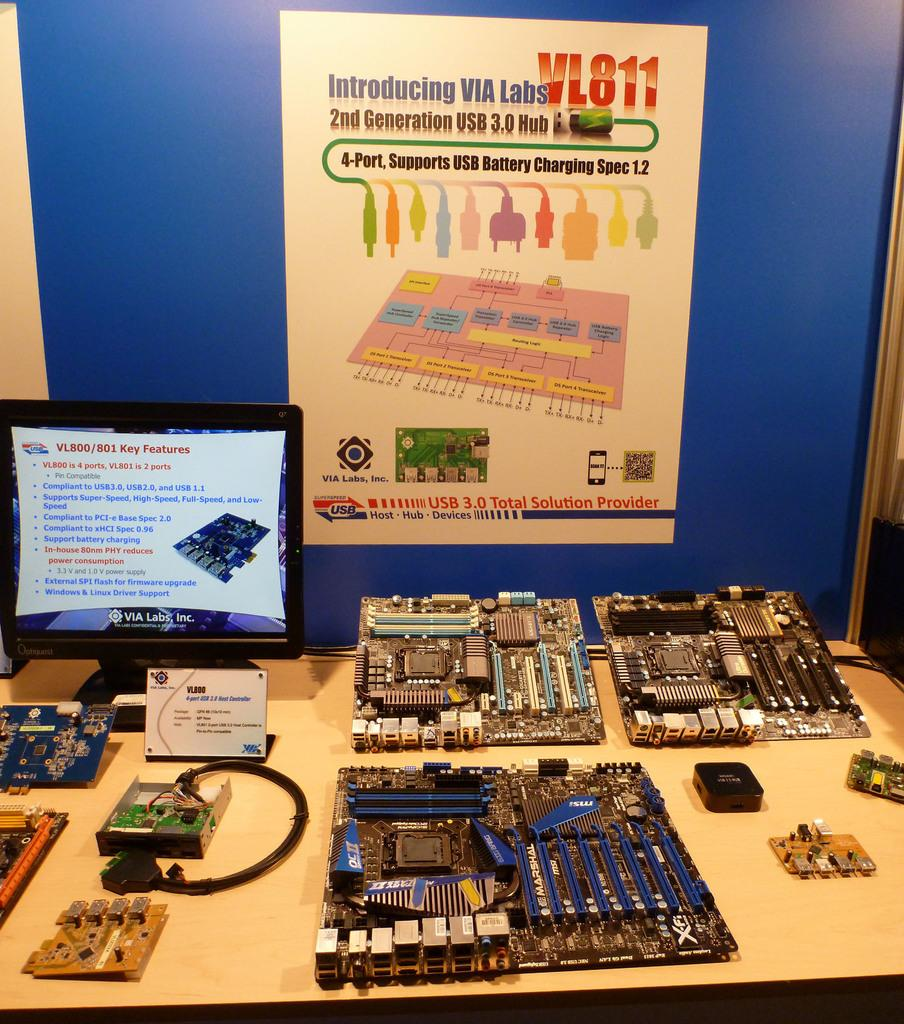<image>
Share a concise interpretation of the image provided. A poster hanging above a table full of electronic components is introducing the new VL811 Hub. 